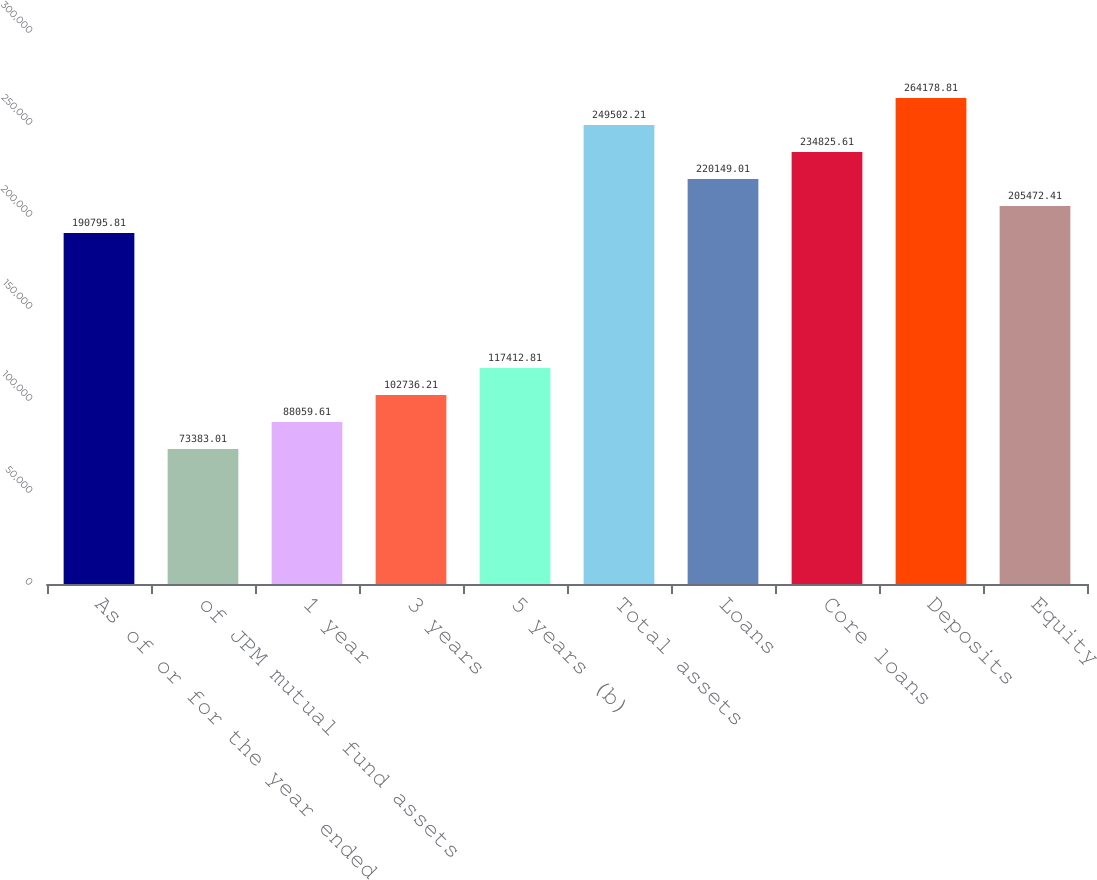Convert chart to OTSL. <chart><loc_0><loc_0><loc_500><loc_500><bar_chart><fcel>As of or for the year ended<fcel>of JPM mutual fund assets<fcel>1 year<fcel>3 years<fcel>5 years (b)<fcel>Total assets<fcel>Loans<fcel>Core loans<fcel>Deposits<fcel>Equity<nl><fcel>190796<fcel>73383<fcel>88059.6<fcel>102736<fcel>117413<fcel>249502<fcel>220149<fcel>234826<fcel>264179<fcel>205472<nl></chart> 